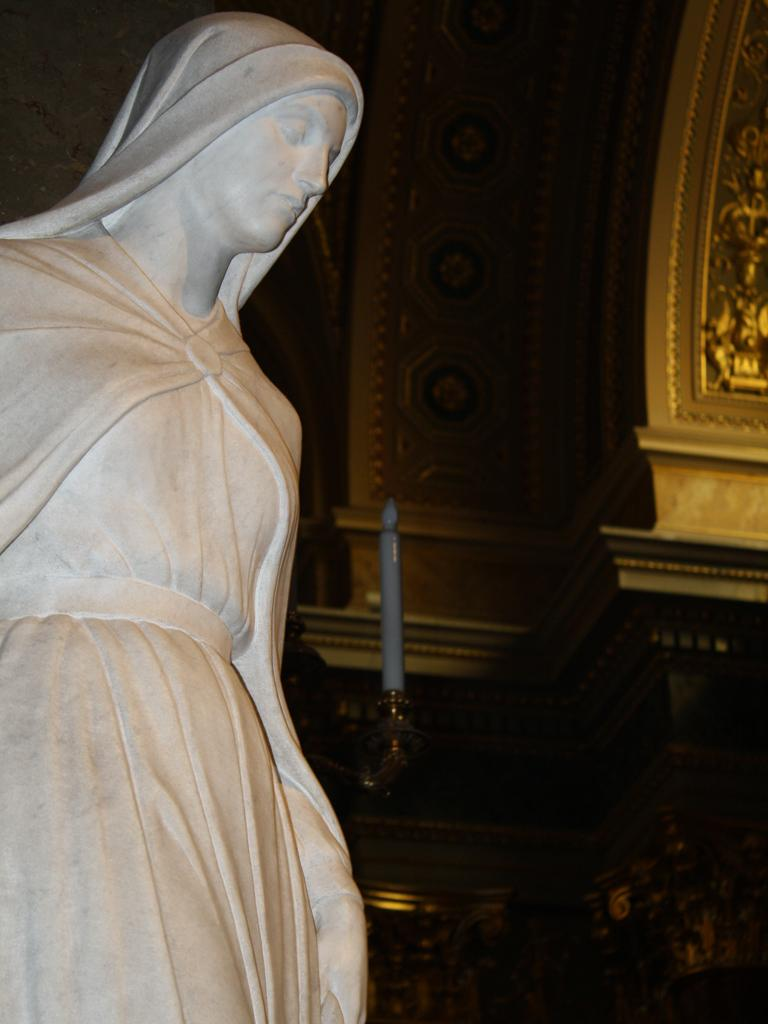What is the main subject of the image? There is a sculpture in the image. What type of drink is being sold by the sculpture in the image? There is no drink being sold by the sculpture in the image, as the fact provided only mentions the presence of a sculpture. 